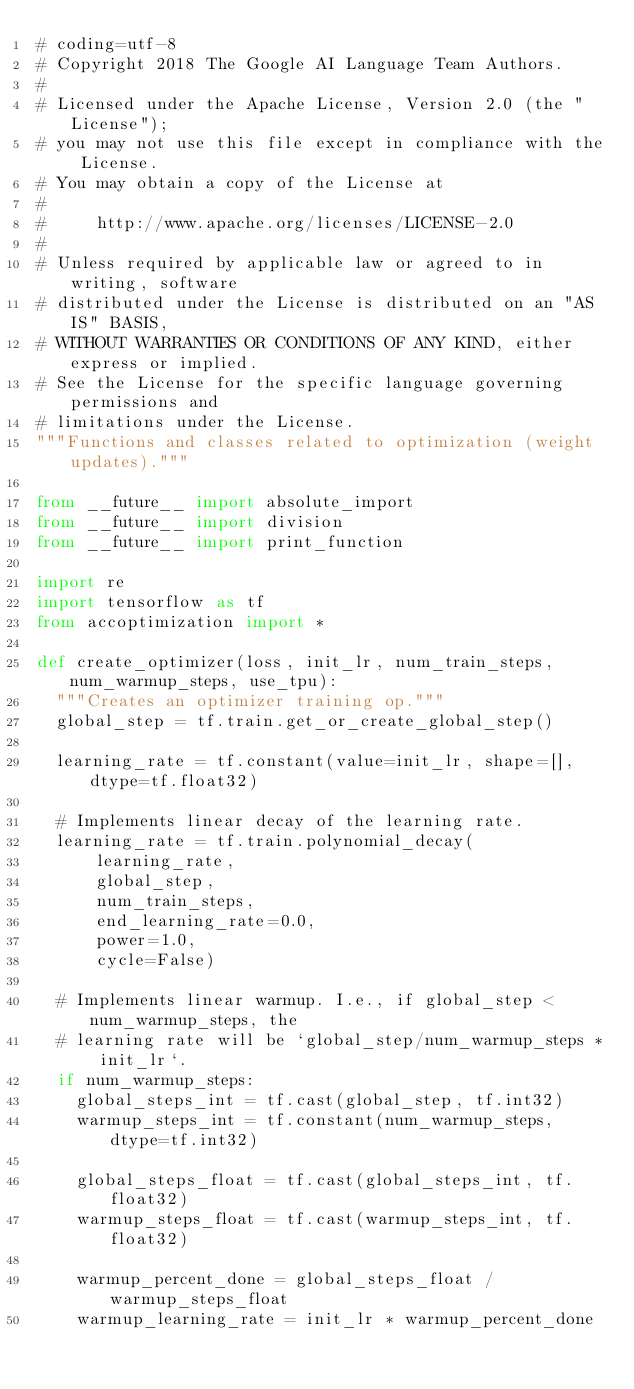Convert code to text. <code><loc_0><loc_0><loc_500><loc_500><_Python_># coding=utf-8
# Copyright 2018 The Google AI Language Team Authors.
#
# Licensed under the Apache License, Version 2.0 (the "License");
# you may not use this file except in compliance with the License.
# You may obtain a copy of the License at
#
#     http://www.apache.org/licenses/LICENSE-2.0
#
# Unless required by applicable law or agreed to in writing, software
# distributed under the License is distributed on an "AS IS" BASIS,
# WITHOUT WARRANTIES OR CONDITIONS OF ANY KIND, either express or implied.
# See the License for the specific language governing permissions and
# limitations under the License.
"""Functions and classes related to optimization (weight updates)."""

from __future__ import absolute_import
from __future__ import division
from __future__ import print_function

import re
import tensorflow as tf
from accoptimization import *

def create_optimizer(loss, init_lr, num_train_steps, num_warmup_steps, use_tpu):
  """Creates an optimizer training op."""
  global_step = tf.train.get_or_create_global_step()

  learning_rate = tf.constant(value=init_lr, shape=[], dtype=tf.float32)

  # Implements linear decay of the learning rate.
  learning_rate = tf.train.polynomial_decay(
      learning_rate,
      global_step,
      num_train_steps,
      end_learning_rate=0.0,
      power=1.0,
      cycle=False)

  # Implements linear warmup. I.e., if global_step < num_warmup_steps, the
  # learning rate will be `global_step/num_warmup_steps * init_lr`.
  if num_warmup_steps:
    global_steps_int = tf.cast(global_step, tf.int32)
    warmup_steps_int = tf.constant(num_warmup_steps, dtype=tf.int32)

    global_steps_float = tf.cast(global_steps_int, tf.float32)
    warmup_steps_float = tf.cast(warmup_steps_int, tf.float32)

    warmup_percent_done = global_steps_float / warmup_steps_float
    warmup_learning_rate = init_lr * warmup_percent_done
</code> 